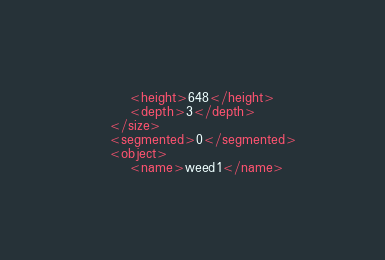Convert code to text. <code><loc_0><loc_0><loc_500><loc_500><_XML_>		<height>648</height>
		<depth>3</depth>
	</size>
	<segmented>0</segmented>
	<object>
		<name>weed1</name></code> 